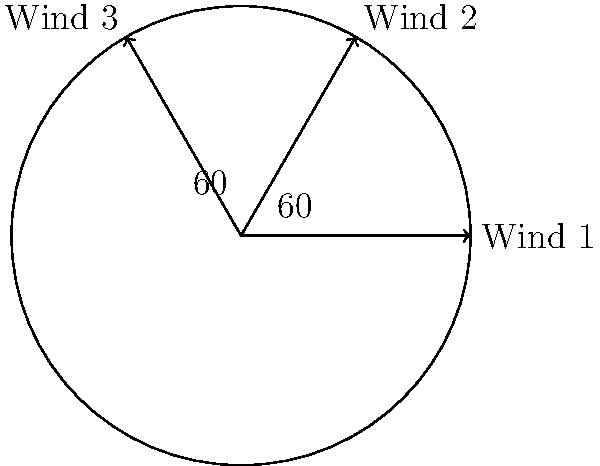A wind turbine is designed to capture wind energy from three primary wind directions, as shown in the diagram. The angles between these wind directions are equal at 60°. If the turbine's efficiency in capturing wind energy is proportional to the cosine of the angle between the wind direction and the turbine's optimal orientation, what is the maximum total efficiency achievable (as a percentage) when the turbine is positioned to capture energy from all three wind directions equally? Let's approach this step-by-step:

1) The turbine's efficiency is proportional to the cosine of the angle between the wind direction and the turbine's orientation. To capture energy from all three directions equally, the turbine should be oriented midway between Wind 1 and Wind 3.

2) This means the turbine will be at a 30° angle from Wind 1 and Wind 3, and at a 30° angle from Wind 2 in the opposite direction.

3) The efficiency for each wind direction will be:

   Wind 1: $\cos(30°)$
   Wind 2: $\cos(30°)$
   Wind 3: $\cos(30°)$

4) We know that $\cos(30°) = \frac{\sqrt{3}}{2} \approx 0.866$

5) The total efficiency is the sum of these three cosines:

   Total Efficiency = $\cos(30°) + \cos(30°) + \cos(30°) = 3 \cos(30°) = 3 \cdot \frac{\sqrt{3}}{2}$

6) To convert to a percentage, we multiply by 100:

   Percentage Efficiency = $3 \cdot \frac{\sqrt{3}}{2} \cdot 100\% = 150\sqrt{3}\% \approx 259.8\%$
Answer: $150\sqrt{3}\%$ or approximately 259.8% 